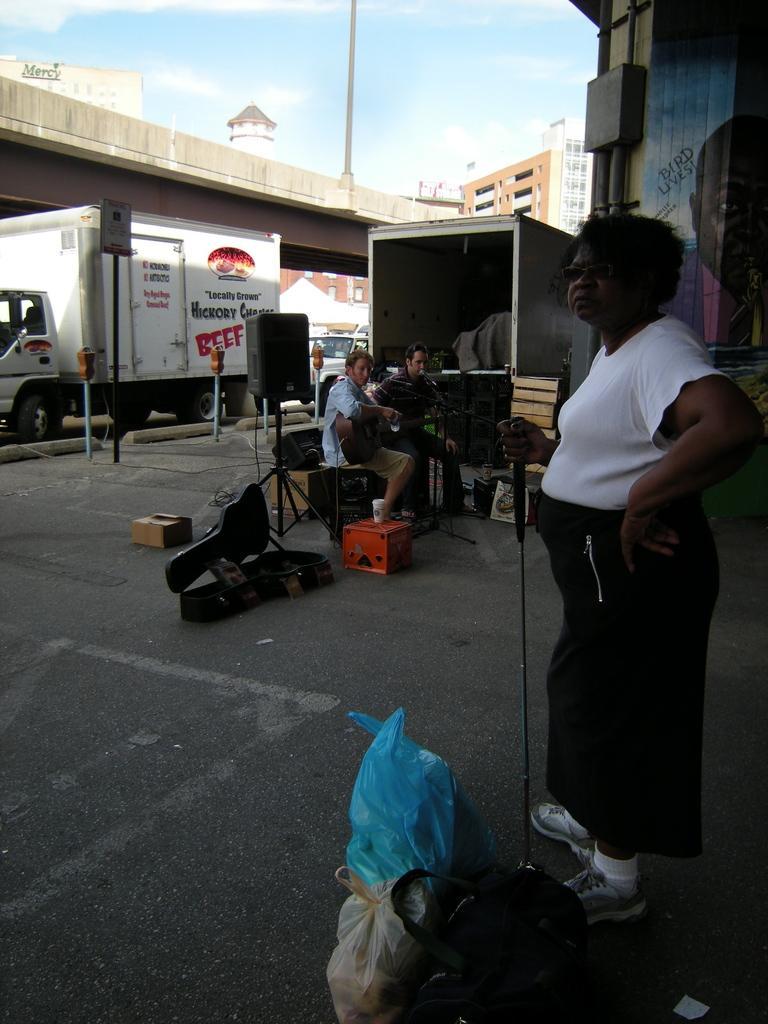How would you summarize this image in a sentence or two? In this image I can see three persons. In front the person is standing and holding some object and the person is wearing white and black color dress and I can see few musical instruments. In the background I can see few vehicles, buildings and the sky is in blue and white color. 